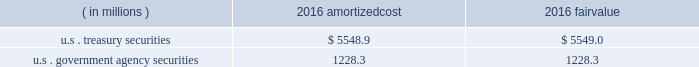Each clearing firm is required to deposit and maintain balances in the form of cash , u.s .
Government securities , certain foreign government securities , bank letters of credit or other approved investments to satisfy performance bond and guaranty fund requirements .
All non-cash deposits are marked-to-market and haircut on a daily basis .
Securities deposited by the clearing firms are not reflected in the consolidated financial statements and the clearing house does not earn any interest on these deposits .
These balances may fluctuate significantly over time due to investment choices available to clearing firms and changes in the amount of contributions required .
In addition , the rules and regulations of cbot require that collateral be provided for delivery of physical commodities , maintenance of capital requirements and deposits on pending arbitration matters .
To satisfy these requirements , clearing firms that have accounts that trade certain cbot products have deposited cash , u.s .
Treasury securities or letters of credit .
The clearing house marks-to-market open positions at least once a day ( twice a day for futures and options contracts ) , and require payment from clearing firms whose positions have lost value and make payments to clearing firms whose positions have gained value .
The clearing house has the capability to mark-to-market more frequently as market conditions warrant .
Under the extremely unlikely scenario of simultaneous default by every clearing firm who has open positions with unrealized losses , the maximum exposure related to positions other than credit default and interest rate swap contracts would be one half day of changes in fair value of all open positions , before considering the clearing houses 2019 ability to access defaulting clearing firms 2019 collateral deposits .
For cleared credit default swap and interest rate swap contracts , the maximum exposure related to cme 2019s guarantee would be one full day of changes in fair value of all open positions , before considering cme 2019s ability to access defaulting clearing firms 2019 collateral .
During 2017 , the clearing house transferred an average of approximately $ 2.4 billion a day through the clearing system for settlement from clearing firms whose positions had lost value to clearing firms whose positions had gained value .
The clearing house reduces the guarantee exposure through initial and maintenance performance bond requirements and mandatory guaranty fund contributions .
The company believes that the guarantee liability is immaterial and therefore has not recorded any liability at december 31 , 2017 .
At december 31 , 2016 , performance bond and guaranty fund contribution assets on the consolidated balance sheets included cash as well as u.s .
Treasury and u.s .
Government agency securities with maturity dates of 90 days or less .
The u.s .
Treasury and u.s .
Government agency securities were purchased by cme , at its discretion , using cash collateral .
The benefits , including interest earned , and risks of ownership accrue to cme .
Interest earned is included in investment income on the consolidated statements of income .
There were no u.s .
Treasury and u.s .
Government agency securities held at december 31 , 2017 .
The amortized cost and fair value of these securities at december 31 , 2016 were as follows : ( in millions ) amortized .
Cme has been designated as a systemically important financial market utility by the financial stability oversight council and maintains a cash account at the federal reserve bank of chicago .
At december 31 , 2017 and december 31 , 2016 , cme maintained $ 34.2 billion and $ 6.2 billion , respectively , within the cash account at the federal reserve bank of chicago .
Clearing firms , at their option , may instruct cme to deposit the cash held by cme into one of the ief programs .
The total principal in the ief programs was $ 1.1 billion at december 31 , 2017 and $ 6.8 billion at december 31 .
In 2016 what was the ratio of the amortizedcost u.s . treasury securities to the u.s . government agency securities? 
Computations: (5548.9 / 1228.3)
Answer: 4.51754. 